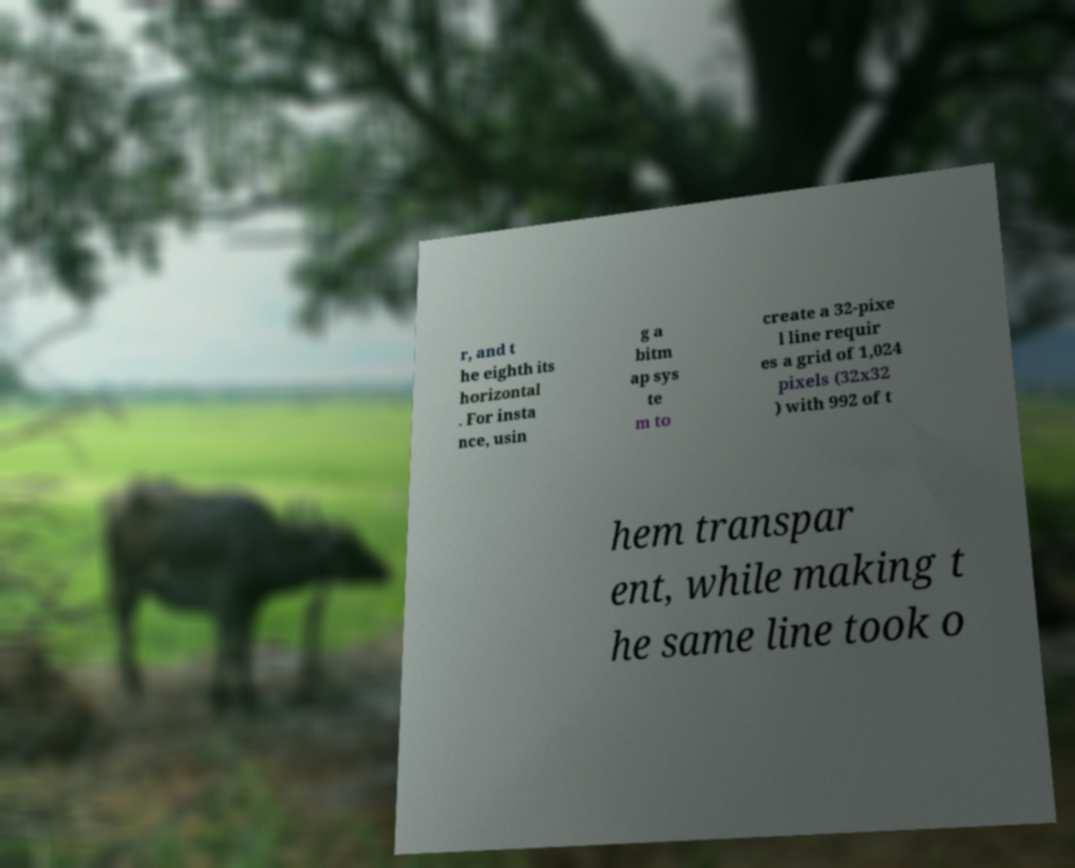Could you assist in decoding the text presented in this image and type it out clearly? r, and t he eighth its horizontal . For insta nce, usin g a bitm ap sys te m to create a 32-pixe l line requir es a grid of 1,024 pixels (32x32 ) with 992 of t hem transpar ent, while making t he same line took o 